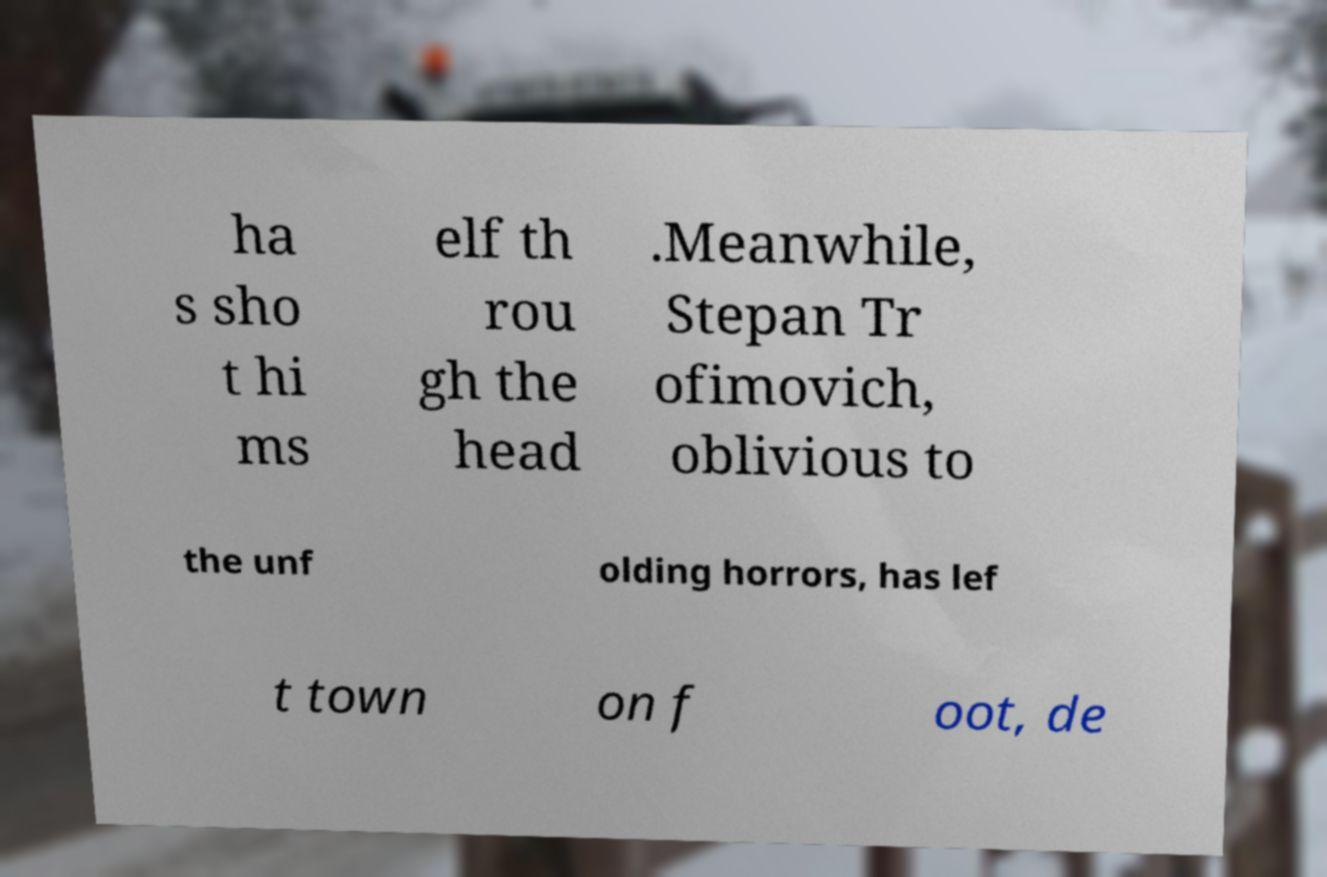Please read and relay the text visible in this image. What does it say? ha s sho t hi ms elf th rou gh the head .Meanwhile, Stepan Tr ofimovich, oblivious to the unf olding horrors, has lef t town on f oot, de 